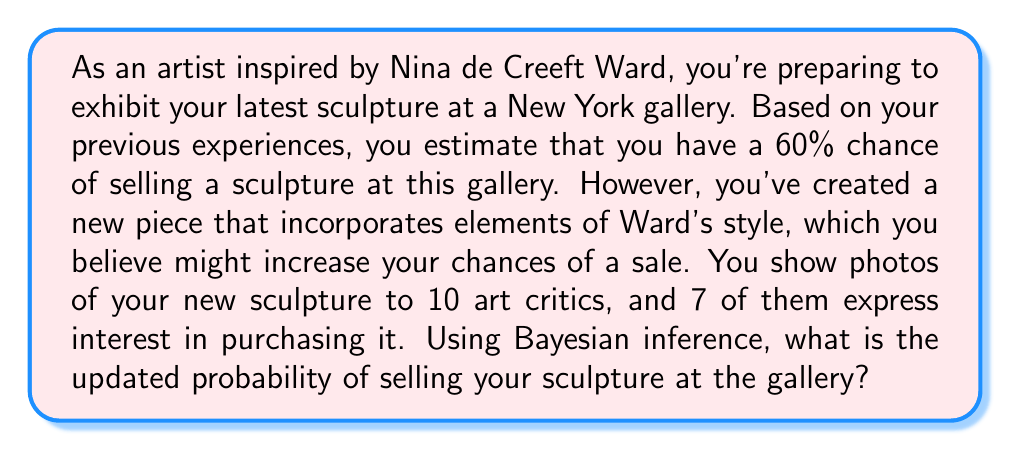Show me your answer to this math problem. To solve this problem using Bayesian inference, we'll follow these steps:

1. Define our variables:
   $P(S)$ = Prior probability of selling a sculpture = 0.60
   $P(I|S)$ = Probability of a critic being interested given that the sculpture will sell
   $P(I|\neg S)$ = Probability of a critic being interested given that the sculpture won't sell
   $P(I)$ = Overall probability of a critic being interested
   $P(S|I)$ = Posterior probability of selling given the critics' interest

2. Estimate $P(I|S)$ and $P(I|\neg S)$:
   Let's assume $P(I|S) = 0.8$ and $P(I|\neg S) = 0.3$

3. Calculate $P(I)$ using the law of total probability:
   $$P(I) = P(I|S)P(S) + P(I|\neg S)P(\neg S)$$
   $$P(I) = 0.8 \times 0.6 + 0.3 \times 0.4 = 0.48 + 0.12 = 0.60$$

4. Apply Bayes' theorem:
   $$P(S|I) = \frac{P(I|S)P(S)}{P(I)}$$

5. Calculate the likelihood of observing 7 interested critics out of 10:
   We can use the binomial distribution:
   $$P(7\text{ out of 10}|S) = \binom{10}{7} \times (0.8)^7 \times (0.2)^3 = 0.2013$$
   $$P(7\text{ out of 10}|\neg S) = \binom{10}{7} \times (0.3)^7 \times (0.7)^3 = 0.0001$$

6. Apply Bayes' theorem with these likelihoods:
   $$P(S|7\text{ out of 10}) = \frac{P(7\text{ out of 10}|S)P(S)}{P(7\text{ out of 10}|S)P(S) + P(7\text{ out of 10}|\neg S)P(\neg S)}$$

7. Plug in the values:
   $$P(S|7\text{ out of 10}) = \frac{0.2013 \times 0.6}{0.2013 \times 0.6 + 0.0001 \times 0.4}$$

8. Calculate the final result:
   $$P(S|7\text{ out of 10}) = \frac{0.12078}{0.12078 + 0.00004} = 0.9997$$

Thus, the updated probability of selling your sculpture at the gallery, given the interest from 7 out of 10 critics, is approximately 0.9997 or 99.97%.
Answer: The updated probability of selling your sculpture at the gallery, given the interest from 7 out of 10 critics, is approximately 0.9997 or 99.97%. 